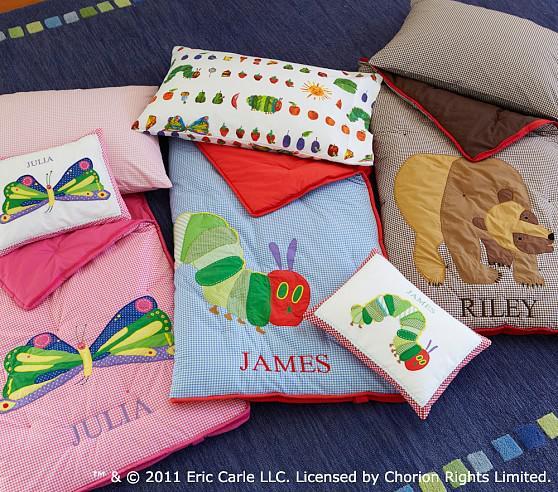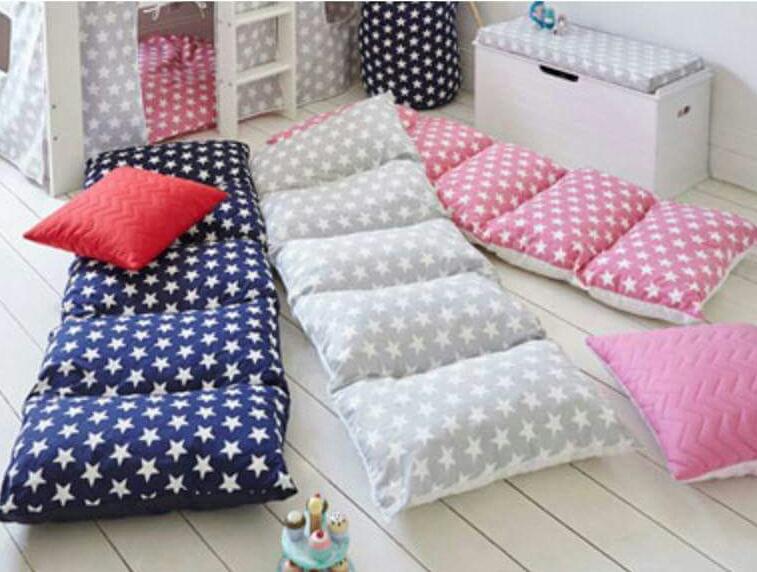The first image is the image on the left, the second image is the image on the right. Examine the images to the left and right. Is the description "At least one piece of fabric has flowers on it." accurate? Answer yes or no. No. The first image is the image on the left, the second image is the image on the right. Examine the images to the left and right. Is the description "An image shows a neutral-colored couch containing a horizontal row of at least four geometric patterned pillows." accurate? Answer yes or no. No. 